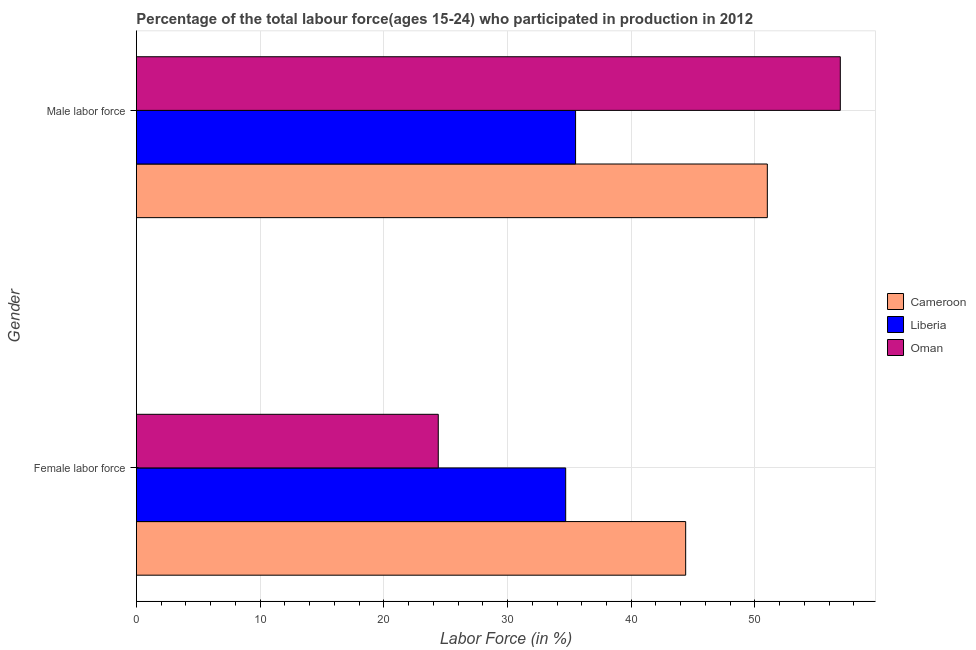How many different coloured bars are there?
Offer a terse response. 3. Are the number of bars per tick equal to the number of legend labels?
Your answer should be very brief. Yes. What is the label of the 2nd group of bars from the top?
Provide a succinct answer. Female labor force. What is the percentage of male labour force in Liberia?
Provide a short and direct response. 35.5. Across all countries, what is the maximum percentage of male labour force?
Your answer should be very brief. 56.9. Across all countries, what is the minimum percentage of male labour force?
Keep it short and to the point. 35.5. In which country was the percentage of female labor force maximum?
Offer a terse response. Cameroon. In which country was the percentage of male labour force minimum?
Keep it short and to the point. Liberia. What is the total percentage of male labour force in the graph?
Provide a short and direct response. 143.4. What is the difference between the percentage of male labour force in Oman and that in Liberia?
Ensure brevity in your answer.  21.4. What is the difference between the percentage of male labour force in Liberia and the percentage of female labor force in Oman?
Ensure brevity in your answer.  11.1. What is the average percentage of female labor force per country?
Keep it short and to the point. 34.5. What is the difference between the percentage of female labor force and percentage of male labour force in Oman?
Keep it short and to the point. -32.5. In how many countries, is the percentage of male labour force greater than 2 %?
Give a very brief answer. 3. What is the ratio of the percentage of female labor force in Oman to that in Cameroon?
Make the answer very short. 0.55. What does the 2nd bar from the top in Male labor force represents?
Ensure brevity in your answer.  Liberia. What does the 3rd bar from the bottom in Male labor force represents?
Offer a very short reply. Oman. Are all the bars in the graph horizontal?
Ensure brevity in your answer.  Yes. Are the values on the major ticks of X-axis written in scientific E-notation?
Make the answer very short. No. How many legend labels are there?
Your answer should be compact. 3. How are the legend labels stacked?
Make the answer very short. Vertical. What is the title of the graph?
Keep it short and to the point. Percentage of the total labour force(ages 15-24) who participated in production in 2012. What is the label or title of the X-axis?
Offer a very short reply. Labor Force (in %). What is the label or title of the Y-axis?
Provide a succinct answer. Gender. What is the Labor Force (in %) in Cameroon in Female labor force?
Make the answer very short. 44.4. What is the Labor Force (in %) in Liberia in Female labor force?
Give a very brief answer. 34.7. What is the Labor Force (in %) of Oman in Female labor force?
Your response must be concise. 24.4. What is the Labor Force (in %) of Liberia in Male labor force?
Your answer should be compact. 35.5. What is the Labor Force (in %) of Oman in Male labor force?
Your answer should be compact. 56.9. Across all Gender, what is the maximum Labor Force (in %) of Liberia?
Ensure brevity in your answer.  35.5. Across all Gender, what is the maximum Labor Force (in %) of Oman?
Keep it short and to the point. 56.9. Across all Gender, what is the minimum Labor Force (in %) in Cameroon?
Ensure brevity in your answer.  44.4. Across all Gender, what is the minimum Labor Force (in %) of Liberia?
Ensure brevity in your answer.  34.7. Across all Gender, what is the minimum Labor Force (in %) of Oman?
Your answer should be very brief. 24.4. What is the total Labor Force (in %) in Cameroon in the graph?
Provide a succinct answer. 95.4. What is the total Labor Force (in %) in Liberia in the graph?
Make the answer very short. 70.2. What is the total Labor Force (in %) of Oman in the graph?
Keep it short and to the point. 81.3. What is the difference between the Labor Force (in %) of Oman in Female labor force and that in Male labor force?
Your answer should be compact. -32.5. What is the difference between the Labor Force (in %) in Liberia in Female labor force and the Labor Force (in %) in Oman in Male labor force?
Provide a succinct answer. -22.2. What is the average Labor Force (in %) of Cameroon per Gender?
Your answer should be compact. 47.7. What is the average Labor Force (in %) of Liberia per Gender?
Give a very brief answer. 35.1. What is the average Labor Force (in %) of Oman per Gender?
Provide a short and direct response. 40.65. What is the difference between the Labor Force (in %) in Cameroon and Labor Force (in %) in Oman in Female labor force?
Ensure brevity in your answer.  20. What is the difference between the Labor Force (in %) of Liberia and Labor Force (in %) of Oman in Female labor force?
Your answer should be compact. 10.3. What is the difference between the Labor Force (in %) in Cameroon and Labor Force (in %) in Oman in Male labor force?
Ensure brevity in your answer.  -5.9. What is the difference between the Labor Force (in %) of Liberia and Labor Force (in %) of Oman in Male labor force?
Ensure brevity in your answer.  -21.4. What is the ratio of the Labor Force (in %) in Cameroon in Female labor force to that in Male labor force?
Make the answer very short. 0.87. What is the ratio of the Labor Force (in %) of Liberia in Female labor force to that in Male labor force?
Offer a very short reply. 0.98. What is the ratio of the Labor Force (in %) in Oman in Female labor force to that in Male labor force?
Provide a succinct answer. 0.43. What is the difference between the highest and the second highest Labor Force (in %) in Cameroon?
Make the answer very short. 6.6. What is the difference between the highest and the second highest Labor Force (in %) of Liberia?
Provide a succinct answer. 0.8. What is the difference between the highest and the second highest Labor Force (in %) in Oman?
Provide a succinct answer. 32.5. What is the difference between the highest and the lowest Labor Force (in %) in Cameroon?
Your response must be concise. 6.6. What is the difference between the highest and the lowest Labor Force (in %) in Liberia?
Your response must be concise. 0.8. What is the difference between the highest and the lowest Labor Force (in %) of Oman?
Provide a short and direct response. 32.5. 